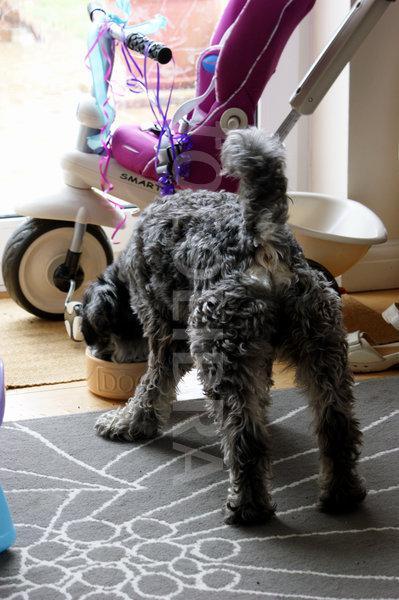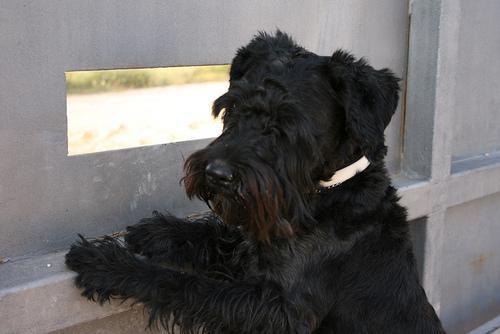The first image is the image on the left, the second image is the image on the right. For the images displayed, is the sentence "One dog is eating and the other dog is not near food." factually correct? Answer yes or no. Yes. 